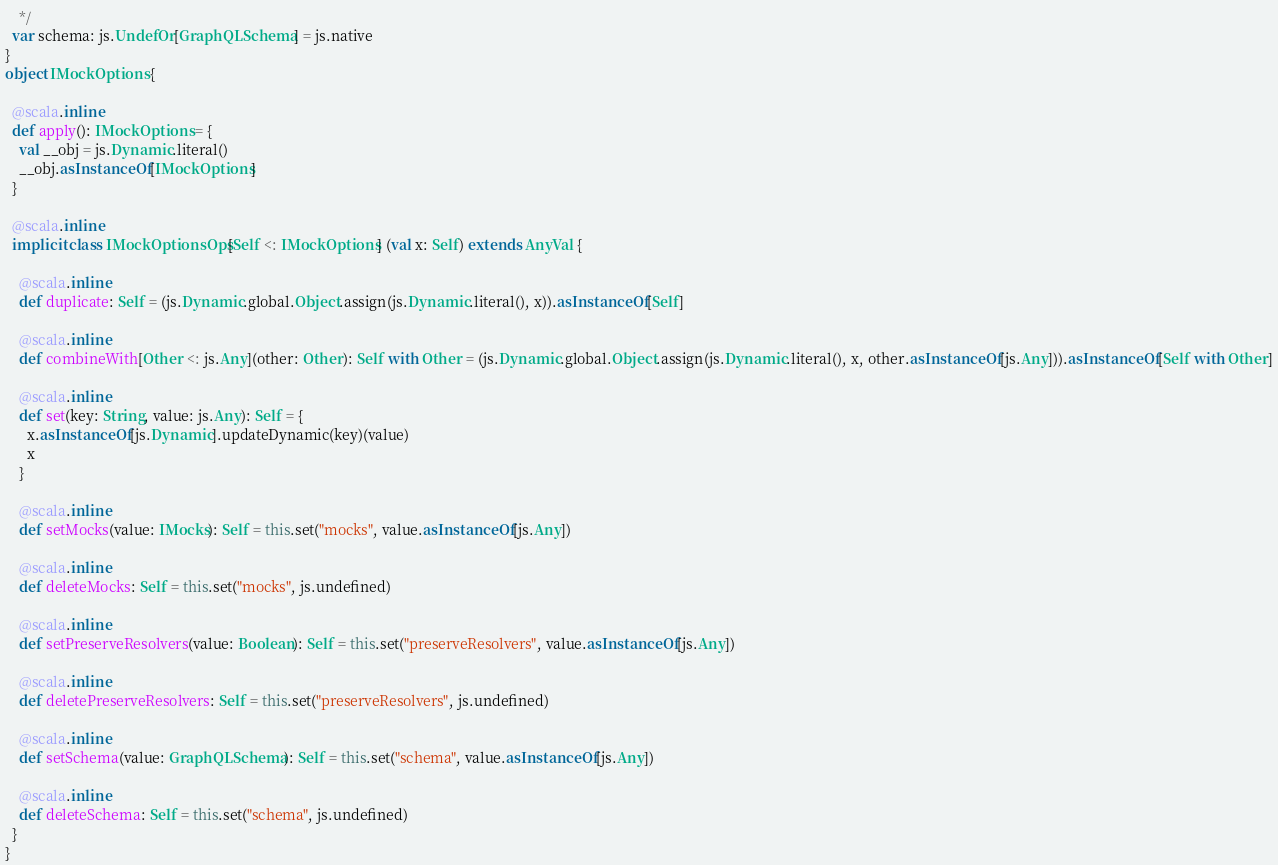<code> <loc_0><loc_0><loc_500><loc_500><_Scala_>    */
  var schema: js.UndefOr[GraphQLSchema] = js.native
}
object IMockOptions {
  
  @scala.inline
  def apply(): IMockOptions = {
    val __obj = js.Dynamic.literal()
    __obj.asInstanceOf[IMockOptions]
  }
  
  @scala.inline
  implicit class IMockOptionsOps[Self <: IMockOptions] (val x: Self) extends AnyVal {
    
    @scala.inline
    def duplicate: Self = (js.Dynamic.global.Object.assign(js.Dynamic.literal(), x)).asInstanceOf[Self]
    
    @scala.inline
    def combineWith[Other <: js.Any](other: Other): Self with Other = (js.Dynamic.global.Object.assign(js.Dynamic.literal(), x, other.asInstanceOf[js.Any])).asInstanceOf[Self with Other]
    
    @scala.inline
    def set(key: String, value: js.Any): Self = {
      x.asInstanceOf[js.Dynamic].updateDynamic(key)(value)
      x
    }
    
    @scala.inline
    def setMocks(value: IMocks): Self = this.set("mocks", value.asInstanceOf[js.Any])
    
    @scala.inline
    def deleteMocks: Self = this.set("mocks", js.undefined)
    
    @scala.inline
    def setPreserveResolvers(value: Boolean): Self = this.set("preserveResolvers", value.asInstanceOf[js.Any])
    
    @scala.inline
    def deletePreserveResolvers: Self = this.set("preserveResolvers", js.undefined)
    
    @scala.inline
    def setSchema(value: GraphQLSchema): Self = this.set("schema", value.asInstanceOf[js.Any])
    
    @scala.inline
    def deleteSchema: Self = this.set("schema", js.undefined)
  }
}
</code> 